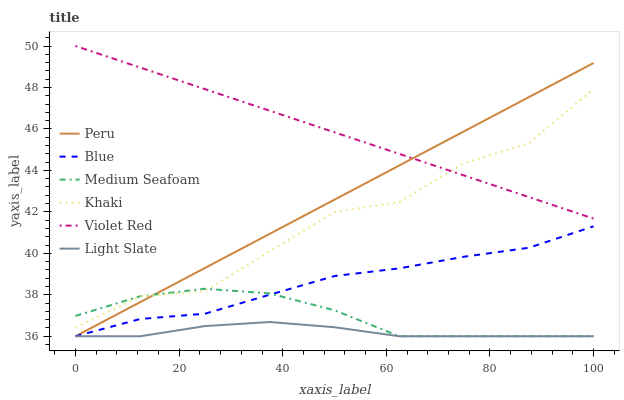Does Light Slate have the minimum area under the curve?
Answer yes or no. Yes. Does Violet Red have the maximum area under the curve?
Answer yes or no. Yes. Does Khaki have the minimum area under the curve?
Answer yes or no. No. Does Khaki have the maximum area under the curve?
Answer yes or no. No. Is Peru the smoothest?
Answer yes or no. Yes. Is Khaki the roughest?
Answer yes or no. Yes. Is Violet Red the smoothest?
Answer yes or no. No. Is Violet Red the roughest?
Answer yes or no. No. Does Blue have the lowest value?
Answer yes or no. Yes. Does Khaki have the lowest value?
Answer yes or no. No. Does Violet Red have the highest value?
Answer yes or no. Yes. Does Khaki have the highest value?
Answer yes or no. No. Is Blue less than Violet Red?
Answer yes or no. Yes. Is Violet Red greater than Blue?
Answer yes or no. Yes. Does Medium Seafoam intersect Peru?
Answer yes or no. Yes. Is Medium Seafoam less than Peru?
Answer yes or no. No. Is Medium Seafoam greater than Peru?
Answer yes or no. No. Does Blue intersect Violet Red?
Answer yes or no. No. 